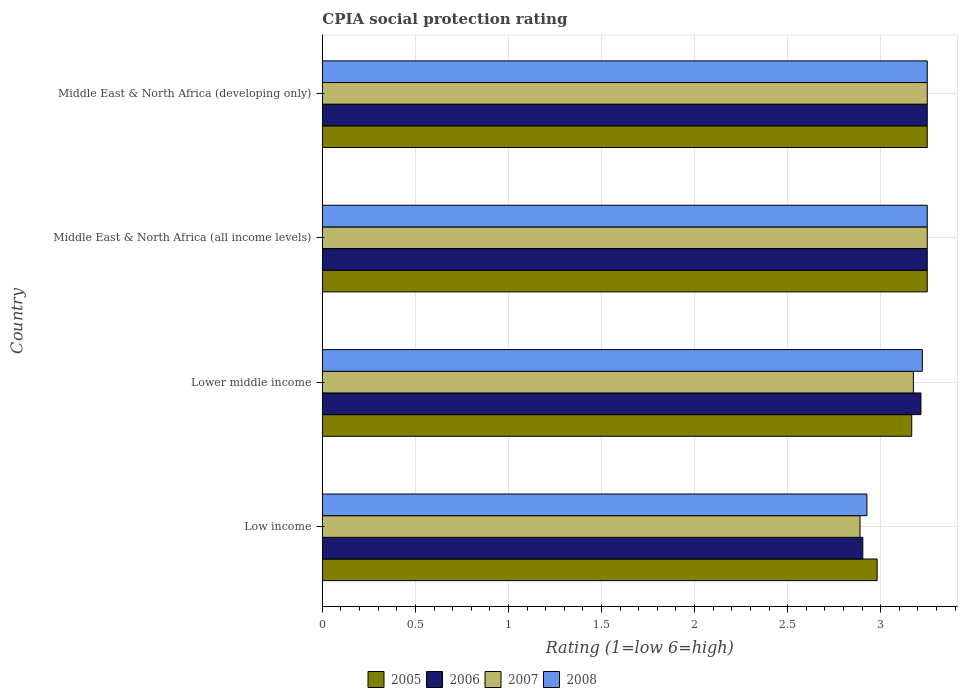How many different coloured bars are there?
Provide a succinct answer. 4. Are the number of bars per tick equal to the number of legend labels?
Your answer should be very brief. Yes. How many bars are there on the 1st tick from the bottom?
Ensure brevity in your answer.  4. What is the label of the 2nd group of bars from the top?
Make the answer very short. Middle East & North Africa (all income levels). Across all countries, what is the minimum CPIA rating in 2006?
Make the answer very short. 2.9. In which country was the CPIA rating in 2005 maximum?
Give a very brief answer. Middle East & North Africa (all income levels). What is the total CPIA rating in 2008 in the graph?
Keep it short and to the point. 12.65. What is the difference between the CPIA rating in 2006 in Middle East & North Africa (all income levels) and that in Middle East & North Africa (developing only)?
Your response must be concise. 0. What is the difference between the CPIA rating in 2006 in Middle East & North Africa (developing only) and the CPIA rating in 2005 in Low income?
Your answer should be compact. 0.27. What is the average CPIA rating in 2007 per country?
Keep it short and to the point. 3.14. What is the difference between the CPIA rating in 2007 and CPIA rating in 2008 in Low income?
Your answer should be very brief. -0.04. In how many countries, is the CPIA rating in 2008 greater than 1.9 ?
Your response must be concise. 4. What is the ratio of the CPIA rating in 2007 in Low income to that in Lower middle income?
Offer a terse response. 0.91. What is the difference between the highest and the second highest CPIA rating in 2005?
Give a very brief answer. 0. What is the difference between the highest and the lowest CPIA rating in 2005?
Your answer should be compact. 0.27. What does the 1st bar from the bottom in Low income represents?
Ensure brevity in your answer.  2005. Is it the case that in every country, the sum of the CPIA rating in 2008 and CPIA rating in 2005 is greater than the CPIA rating in 2006?
Offer a terse response. Yes. How many bars are there?
Offer a very short reply. 16. Are all the bars in the graph horizontal?
Offer a very short reply. Yes. How many countries are there in the graph?
Provide a short and direct response. 4. Are the values on the major ticks of X-axis written in scientific E-notation?
Provide a succinct answer. No. What is the title of the graph?
Provide a short and direct response. CPIA social protection rating. Does "1965" appear as one of the legend labels in the graph?
Provide a short and direct response. No. What is the label or title of the X-axis?
Offer a very short reply. Rating (1=low 6=high). What is the Rating (1=low 6=high) of 2005 in Low income?
Your answer should be very brief. 2.98. What is the Rating (1=low 6=high) of 2006 in Low income?
Make the answer very short. 2.9. What is the Rating (1=low 6=high) in 2007 in Low income?
Ensure brevity in your answer.  2.89. What is the Rating (1=low 6=high) in 2008 in Low income?
Provide a short and direct response. 2.93. What is the Rating (1=low 6=high) of 2005 in Lower middle income?
Your answer should be very brief. 3.17. What is the Rating (1=low 6=high) of 2006 in Lower middle income?
Ensure brevity in your answer.  3.22. What is the Rating (1=low 6=high) of 2007 in Lower middle income?
Your answer should be compact. 3.18. What is the Rating (1=low 6=high) in 2008 in Lower middle income?
Give a very brief answer. 3.22. What is the Rating (1=low 6=high) in 2008 in Middle East & North Africa (all income levels)?
Your answer should be compact. 3.25. Across all countries, what is the maximum Rating (1=low 6=high) of 2005?
Offer a very short reply. 3.25. Across all countries, what is the maximum Rating (1=low 6=high) in 2006?
Your response must be concise. 3.25. Across all countries, what is the maximum Rating (1=low 6=high) of 2007?
Offer a very short reply. 3.25. Across all countries, what is the maximum Rating (1=low 6=high) in 2008?
Keep it short and to the point. 3.25. Across all countries, what is the minimum Rating (1=low 6=high) of 2005?
Your response must be concise. 2.98. Across all countries, what is the minimum Rating (1=low 6=high) in 2006?
Offer a very short reply. 2.9. Across all countries, what is the minimum Rating (1=low 6=high) of 2007?
Offer a terse response. 2.89. Across all countries, what is the minimum Rating (1=low 6=high) of 2008?
Offer a very short reply. 2.93. What is the total Rating (1=low 6=high) in 2005 in the graph?
Keep it short and to the point. 12.65. What is the total Rating (1=low 6=high) of 2006 in the graph?
Offer a very short reply. 12.62. What is the total Rating (1=low 6=high) in 2007 in the graph?
Your answer should be very brief. 12.56. What is the total Rating (1=low 6=high) in 2008 in the graph?
Keep it short and to the point. 12.65. What is the difference between the Rating (1=low 6=high) of 2005 in Low income and that in Lower middle income?
Your answer should be very brief. -0.19. What is the difference between the Rating (1=low 6=high) in 2006 in Low income and that in Lower middle income?
Offer a terse response. -0.31. What is the difference between the Rating (1=low 6=high) in 2007 in Low income and that in Lower middle income?
Offer a very short reply. -0.29. What is the difference between the Rating (1=low 6=high) in 2008 in Low income and that in Lower middle income?
Your answer should be compact. -0.3. What is the difference between the Rating (1=low 6=high) of 2005 in Low income and that in Middle East & North Africa (all income levels)?
Your answer should be compact. -0.27. What is the difference between the Rating (1=low 6=high) in 2006 in Low income and that in Middle East & North Africa (all income levels)?
Provide a short and direct response. -0.35. What is the difference between the Rating (1=low 6=high) of 2007 in Low income and that in Middle East & North Africa (all income levels)?
Provide a succinct answer. -0.36. What is the difference between the Rating (1=low 6=high) of 2008 in Low income and that in Middle East & North Africa (all income levels)?
Your answer should be compact. -0.32. What is the difference between the Rating (1=low 6=high) in 2005 in Low income and that in Middle East & North Africa (developing only)?
Your answer should be very brief. -0.27. What is the difference between the Rating (1=low 6=high) in 2006 in Low income and that in Middle East & North Africa (developing only)?
Provide a short and direct response. -0.35. What is the difference between the Rating (1=low 6=high) of 2007 in Low income and that in Middle East & North Africa (developing only)?
Offer a terse response. -0.36. What is the difference between the Rating (1=low 6=high) in 2008 in Low income and that in Middle East & North Africa (developing only)?
Make the answer very short. -0.32. What is the difference between the Rating (1=low 6=high) in 2005 in Lower middle income and that in Middle East & North Africa (all income levels)?
Your response must be concise. -0.08. What is the difference between the Rating (1=low 6=high) of 2006 in Lower middle income and that in Middle East & North Africa (all income levels)?
Offer a very short reply. -0.03. What is the difference between the Rating (1=low 6=high) in 2007 in Lower middle income and that in Middle East & North Africa (all income levels)?
Your response must be concise. -0.07. What is the difference between the Rating (1=low 6=high) of 2008 in Lower middle income and that in Middle East & North Africa (all income levels)?
Your response must be concise. -0.03. What is the difference between the Rating (1=low 6=high) in 2005 in Lower middle income and that in Middle East & North Africa (developing only)?
Make the answer very short. -0.08. What is the difference between the Rating (1=low 6=high) of 2006 in Lower middle income and that in Middle East & North Africa (developing only)?
Keep it short and to the point. -0.03. What is the difference between the Rating (1=low 6=high) of 2007 in Lower middle income and that in Middle East & North Africa (developing only)?
Ensure brevity in your answer.  -0.07. What is the difference between the Rating (1=low 6=high) of 2008 in Lower middle income and that in Middle East & North Africa (developing only)?
Make the answer very short. -0.03. What is the difference between the Rating (1=low 6=high) of 2005 in Middle East & North Africa (all income levels) and that in Middle East & North Africa (developing only)?
Provide a succinct answer. 0. What is the difference between the Rating (1=low 6=high) of 2005 in Low income and the Rating (1=low 6=high) of 2006 in Lower middle income?
Make the answer very short. -0.24. What is the difference between the Rating (1=low 6=high) of 2005 in Low income and the Rating (1=low 6=high) of 2007 in Lower middle income?
Your response must be concise. -0.19. What is the difference between the Rating (1=low 6=high) in 2005 in Low income and the Rating (1=low 6=high) in 2008 in Lower middle income?
Keep it short and to the point. -0.24. What is the difference between the Rating (1=low 6=high) in 2006 in Low income and the Rating (1=low 6=high) in 2007 in Lower middle income?
Your response must be concise. -0.27. What is the difference between the Rating (1=low 6=high) in 2006 in Low income and the Rating (1=low 6=high) in 2008 in Lower middle income?
Offer a very short reply. -0.32. What is the difference between the Rating (1=low 6=high) of 2007 in Low income and the Rating (1=low 6=high) of 2008 in Lower middle income?
Your response must be concise. -0.33. What is the difference between the Rating (1=low 6=high) in 2005 in Low income and the Rating (1=low 6=high) in 2006 in Middle East & North Africa (all income levels)?
Make the answer very short. -0.27. What is the difference between the Rating (1=low 6=high) in 2005 in Low income and the Rating (1=low 6=high) in 2007 in Middle East & North Africa (all income levels)?
Keep it short and to the point. -0.27. What is the difference between the Rating (1=low 6=high) in 2005 in Low income and the Rating (1=low 6=high) in 2008 in Middle East & North Africa (all income levels)?
Your answer should be very brief. -0.27. What is the difference between the Rating (1=low 6=high) in 2006 in Low income and the Rating (1=low 6=high) in 2007 in Middle East & North Africa (all income levels)?
Make the answer very short. -0.35. What is the difference between the Rating (1=low 6=high) in 2006 in Low income and the Rating (1=low 6=high) in 2008 in Middle East & North Africa (all income levels)?
Keep it short and to the point. -0.35. What is the difference between the Rating (1=low 6=high) in 2007 in Low income and the Rating (1=low 6=high) in 2008 in Middle East & North Africa (all income levels)?
Your answer should be very brief. -0.36. What is the difference between the Rating (1=low 6=high) in 2005 in Low income and the Rating (1=low 6=high) in 2006 in Middle East & North Africa (developing only)?
Ensure brevity in your answer.  -0.27. What is the difference between the Rating (1=low 6=high) in 2005 in Low income and the Rating (1=low 6=high) in 2007 in Middle East & North Africa (developing only)?
Your answer should be very brief. -0.27. What is the difference between the Rating (1=low 6=high) of 2005 in Low income and the Rating (1=low 6=high) of 2008 in Middle East & North Africa (developing only)?
Offer a very short reply. -0.27. What is the difference between the Rating (1=low 6=high) of 2006 in Low income and the Rating (1=low 6=high) of 2007 in Middle East & North Africa (developing only)?
Provide a short and direct response. -0.35. What is the difference between the Rating (1=low 6=high) in 2006 in Low income and the Rating (1=low 6=high) in 2008 in Middle East & North Africa (developing only)?
Your answer should be compact. -0.35. What is the difference between the Rating (1=low 6=high) in 2007 in Low income and the Rating (1=low 6=high) in 2008 in Middle East & North Africa (developing only)?
Offer a terse response. -0.36. What is the difference between the Rating (1=low 6=high) in 2005 in Lower middle income and the Rating (1=low 6=high) in 2006 in Middle East & North Africa (all income levels)?
Offer a very short reply. -0.08. What is the difference between the Rating (1=low 6=high) of 2005 in Lower middle income and the Rating (1=low 6=high) of 2007 in Middle East & North Africa (all income levels)?
Give a very brief answer. -0.08. What is the difference between the Rating (1=low 6=high) of 2005 in Lower middle income and the Rating (1=low 6=high) of 2008 in Middle East & North Africa (all income levels)?
Your answer should be very brief. -0.08. What is the difference between the Rating (1=low 6=high) in 2006 in Lower middle income and the Rating (1=low 6=high) in 2007 in Middle East & North Africa (all income levels)?
Make the answer very short. -0.03. What is the difference between the Rating (1=low 6=high) in 2006 in Lower middle income and the Rating (1=low 6=high) in 2008 in Middle East & North Africa (all income levels)?
Your answer should be compact. -0.03. What is the difference between the Rating (1=low 6=high) of 2007 in Lower middle income and the Rating (1=low 6=high) of 2008 in Middle East & North Africa (all income levels)?
Your answer should be compact. -0.07. What is the difference between the Rating (1=low 6=high) of 2005 in Lower middle income and the Rating (1=low 6=high) of 2006 in Middle East & North Africa (developing only)?
Keep it short and to the point. -0.08. What is the difference between the Rating (1=low 6=high) in 2005 in Lower middle income and the Rating (1=low 6=high) in 2007 in Middle East & North Africa (developing only)?
Ensure brevity in your answer.  -0.08. What is the difference between the Rating (1=low 6=high) in 2005 in Lower middle income and the Rating (1=low 6=high) in 2008 in Middle East & North Africa (developing only)?
Ensure brevity in your answer.  -0.08. What is the difference between the Rating (1=low 6=high) of 2006 in Lower middle income and the Rating (1=low 6=high) of 2007 in Middle East & North Africa (developing only)?
Your response must be concise. -0.03. What is the difference between the Rating (1=low 6=high) of 2006 in Lower middle income and the Rating (1=low 6=high) of 2008 in Middle East & North Africa (developing only)?
Your answer should be compact. -0.03. What is the difference between the Rating (1=low 6=high) in 2007 in Lower middle income and the Rating (1=low 6=high) in 2008 in Middle East & North Africa (developing only)?
Your answer should be compact. -0.07. What is the difference between the Rating (1=low 6=high) of 2005 in Middle East & North Africa (all income levels) and the Rating (1=low 6=high) of 2006 in Middle East & North Africa (developing only)?
Provide a short and direct response. 0. What is the difference between the Rating (1=low 6=high) in 2007 in Middle East & North Africa (all income levels) and the Rating (1=low 6=high) in 2008 in Middle East & North Africa (developing only)?
Give a very brief answer. 0. What is the average Rating (1=low 6=high) in 2005 per country?
Provide a succinct answer. 3.16. What is the average Rating (1=low 6=high) in 2006 per country?
Ensure brevity in your answer.  3.15. What is the average Rating (1=low 6=high) of 2007 per country?
Your answer should be compact. 3.14. What is the average Rating (1=low 6=high) in 2008 per country?
Provide a short and direct response. 3.16. What is the difference between the Rating (1=low 6=high) in 2005 and Rating (1=low 6=high) in 2006 in Low income?
Keep it short and to the point. 0.08. What is the difference between the Rating (1=low 6=high) in 2005 and Rating (1=low 6=high) in 2007 in Low income?
Your response must be concise. 0.09. What is the difference between the Rating (1=low 6=high) of 2005 and Rating (1=low 6=high) of 2008 in Low income?
Offer a terse response. 0.05. What is the difference between the Rating (1=low 6=high) of 2006 and Rating (1=low 6=high) of 2007 in Low income?
Offer a very short reply. 0.01. What is the difference between the Rating (1=low 6=high) in 2006 and Rating (1=low 6=high) in 2008 in Low income?
Your answer should be compact. -0.02. What is the difference between the Rating (1=low 6=high) of 2007 and Rating (1=low 6=high) of 2008 in Low income?
Offer a very short reply. -0.04. What is the difference between the Rating (1=low 6=high) in 2005 and Rating (1=low 6=high) in 2006 in Lower middle income?
Your answer should be very brief. -0.05. What is the difference between the Rating (1=low 6=high) of 2005 and Rating (1=low 6=high) of 2007 in Lower middle income?
Your response must be concise. -0.01. What is the difference between the Rating (1=low 6=high) of 2005 and Rating (1=low 6=high) of 2008 in Lower middle income?
Provide a succinct answer. -0.06. What is the difference between the Rating (1=low 6=high) of 2006 and Rating (1=low 6=high) of 2007 in Lower middle income?
Keep it short and to the point. 0.04. What is the difference between the Rating (1=low 6=high) in 2006 and Rating (1=low 6=high) in 2008 in Lower middle income?
Your response must be concise. -0.01. What is the difference between the Rating (1=low 6=high) in 2007 and Rating (1=low 6=high) in 2008 in Lower middle income?
Keep it short and to the point. -0.05. What is the difference between the Rating (1=low 6=high) in 2005 and Rating (1=low 6=high) in 2007 in Middle East & North Africa (all income levels)?
Offer a very short reply. 0. What is the difference between the Rating (1=low 6=high) of 2005 and Rating (1=low 6=high) of 2008 in Middle East & North Africa (all income levels)?
Ensure brevity in your answer.  0. What is the difference between the Rating (1=low 6=high) of 2006 and Rating (1=low 6=high) of 2007 in Middle East & North Africa (all income levels)?
Give a very brief answer. 0. What is the difference between the Rating (1=low 6=high) of 2007 and Rating (1=low 6=high) of 2008 in Middle East & North Africa (all income levels)?
Make the answer very short. 0. What is the difference between the Rating (1=low 6=high) in 2005 and Rating (1=low 6=high) in 2006 in Middle East & North Africa (developing only)?
Your answer should be very brief. 0. What is the difference between the Rating (1=low 6=high) of 2005 and Rating (1=low 6=high) of 2008 in Middle East & North Africa (developing only)?
Offer a very short reply. 0. What is the difference between the Rating (1=low 6=high) of 2006 and Rating (1=low 6=high) of 2007 in Middle East & North Africa (developing only)?
Give a very brief answer. 0. What is the ratio of the Rating (1=low 6=high) in 2005 in Low income to that in Lower middle income?
Provide a short and direct response. 0.94. What is the ratio of the Rating (1=low 6=high) in 2006 in Low income to that in Lower middle income?
Your answer should be compact. 0.9. What is the ratio of the Rating (1=low 6=high) of 2007 in Low income to that in Lower middle income?
Make the answer very short. 0.91. What is the ratio of the Rating (1=low 6=high) of 2008 in Low income to that in Lower middle income?
Your response must be concise. 0.91. What is the ratio of the Rating (1=low 6=high) in 2005 in Low income to that in Middle East & North Africa (all income levels)?
Offer a very short reply. 0.92. What is the ratio of the Rating (1=low 6=high) in 2006 in Low income to that in Middle East & North Africa (all income levels)?
Give a very brief answer. 0.89. What is the ratio of the Rating (1=low 6=high) in 2007 in Low income to that in Middle East & North Africa (all income levels)?
Your response must be concise. 0.89. What is the ratio of the Rating (1=low 6=high) of 2008 in Low income to that in Middle East & North Africa (all income levels)?
Your response must be concise. 0.9. What is the ratio of the Rating (1=low 6=high) in 2005 in Low income to that in Middle East & North Africa (developing only)?
Provide a short and direct response. 0.92. What is the ratio of the Rating (1=low 6=high) of 2006 in Low income to that in Middle East & North Africa (developing only)?
Provide a short and direct response. 0.89. What is the ratio of the Rating (1=low 6=high) of 2008 in Low income to that in Middle East & North Africa (developing only)?
Provide a succinct answer. 0.9. What is the ratio of the Rating (1=low 6=high) of 2005 in Lower middle income to that in Middle East & North Africa (all income levels)?
Ensure brevity in your answer.  0.97. What is the ratio of the Rating (1=low 6=high) of 2006 in Lower middle income to that in Middle East & North Africa (all income levels)?
Keep it short and to the point. 0.99. What is the ratio of the Rating (1=low 6=high) of 2007 in Lower middle income to that in Middle East & North Africa (all income levels)?
Make the answer very short. 0.98. What is the ratio of the Rating (1=low 6=high) of 2005 in Lower middle income to that in Middle East & North Africa (developing only)?
Offer a terse response. 0.97. What is the ratio of the Rating (1=low 6=high) of 2006 in Lower middle income to that in Middle East & North Africa (developing only)?
Offer a very short reply. 0.99. What is the ratio of the Rating (1=low 6=high) of 2007 in Lower middle income to that in Middle East & North Africa (developing only)?
Provide a succinct answer. 0.98. What is the ratio of the Rating (1=low 6=high) of 2008 in Lower middle income to that in Middle East & North Africa (developing only)?
Give a very brief answer. 0.99. What is the ratio of the Rating (1=low 6=high) of 2007 in Middle East & North Africa (all income levels) to that in Middle East & North Africa (developing only)?
Offer a very short reply. 1. What is the difference between the highest and the second highest Rating (1=low 6=high) in 2008?
Your response must be concise. 0. What is the difference between the highest and the lowest Rating (1=low 6=high) in 2005?
Your answer should be compact. 0.27. What is the difference between the highest and the lowest Rating (1=low 6=high) of 2006?
Offer a terse response. 0.35. What is the difference between the highest and the lowest Rating (1=low 6=high) in 2007?
Give a very brief answer. 0.36. What is the difference between the highest and the lowest Rating (1=low 6=high) of 2008?
Provide a short and direct response. 0.32. 